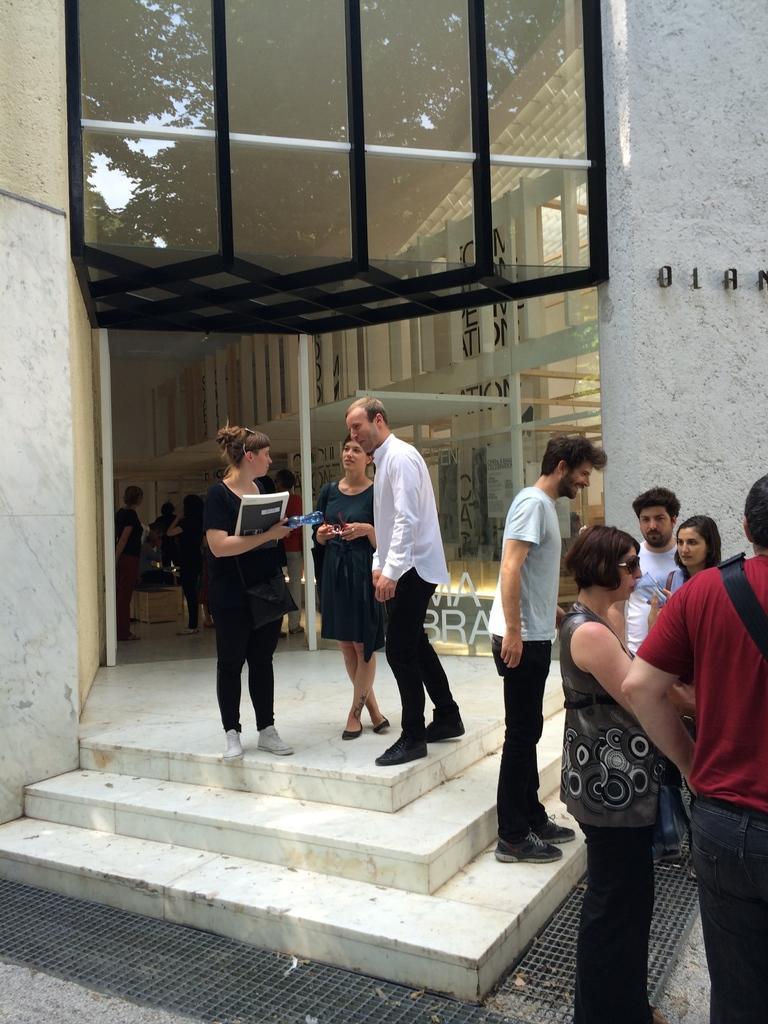Describe this image in one or two sentences. On the right side, we see the people are standing. At the bottom, we see the staircase and the people are standing. The woman on the left side is holding a book and a water bottle in her hands. Behind her, we see a building and we see a glass door. Behind that, we see the people are standing. On the right side, we see the poles and a wall in white color. At the bottom, we see a grey color mat. 